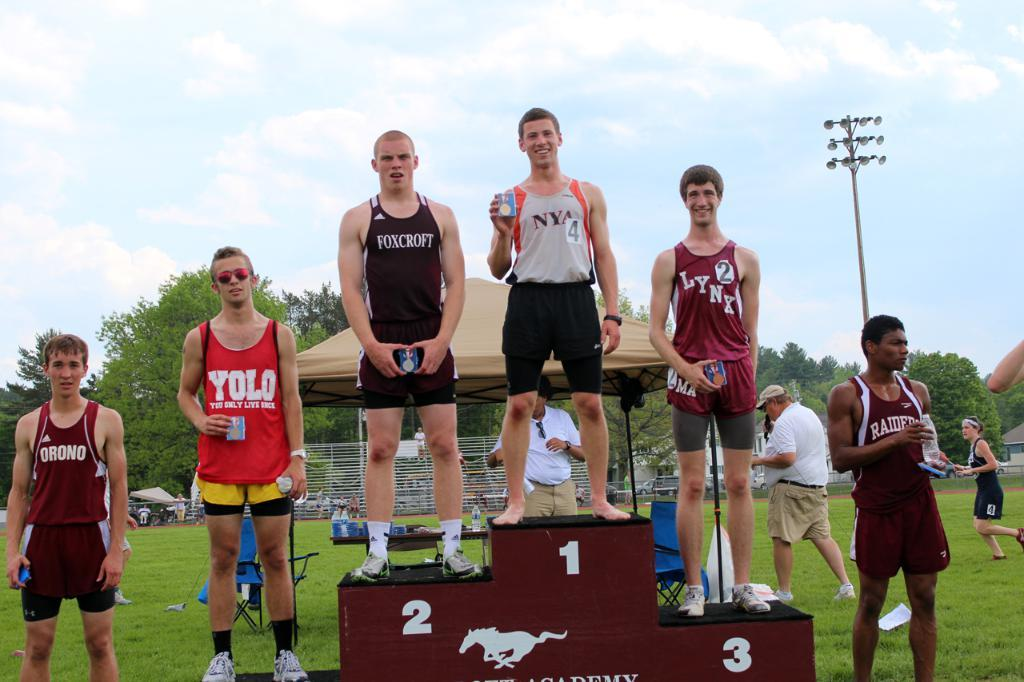<image>
Relay a brief, clear account of the picture shown. Men standing on a podium with the first place man wearing a NYA shirt 